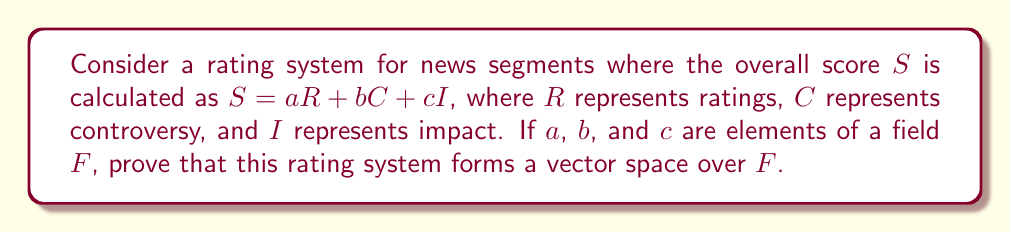Can you solve this math problem? To prove that the rating system forms a vector space over field $F$, we need to show that it satisfies the eight vector space axioms:

1. Closure under addition:
Let $S_1 = a_1R + b_1C + c_1I$ and $S_2 = a_2R + b_2C + c_2I$
$S_1 + S_2 = (a_1 + a_2)R + (b_1 + b_2)C + (c_1 + c_2)I$
Since $a_1 + a_2$, $b_1 + b_2$, and $c_1 + c_2$ are in $F$, $S_1 + S_2$ is in the vector space.

2. Commutativity of addition:
$S_1 + S_2 = (a_1 + a_2)R + (b_1 + b_2)C + (c_1 + c_2)I$
$= (a_2 + a_1)R + (b_2 + b_1)C + (c_2 + c_1)I = S_2 + S_1$

3. Associativity of addition:
$(S_1 + S_2) + S_3 = ((a_1 + a_2) + a_3)R + ((b_1 + b_2) + b_3)C + ((c_1 + c_2) + c_3)I$
$= (a_1 + (a_2 + a_3))R + (b_1 + (b_2 + b_3))C + (c_1 + (c_2 + c_3))I = S_1 + (S_2 + S_3)$

4. Additive identity:
The zero vector is $0 = 0R + 0C + 0I$, where $0 \in F$
$S + 0 = (a + 0)R + (b + 0)C + (c + 0)I = S$

5. Additive inverse:
For any $S = aR + bC + cI$, its additive inverse is $-S = (-a)R + (-b)C + (-c)I$
$S + (-S) = (a + (-a))R + (b + (-b))C + (c + (-c))I = 0R + 0C + 0I = 0$

6. Closure under scalar multiplication:
For any scalar $k \in F$ and $S = aR + bC + cI$
$kS = (ka)R + (kb)C + (kc)I$
Since $ka$, $kb$, and $kc$ are in $F$, $kS$ is in the vector space.

7. Distributivity of scalar multiplication with respect to vector addition:
$k(S_1 + S_2) = k((a_1 + a_2)R + (b_1 + b_2)C + (c_1 + c_2)I)$
$= (k(a_1 + a_2))R + (k(b_1 + b_2))C + (k(c_1 + c_2))I$
$= (ka_1 + ka_2)R + (kb_1 + kb_2)C + (kc_1 + kc_2)I$
$= (ka_1R + kb_1C + kc_1I) + (ka_2R + kb_2C + kc_2I) = kS_1 + kS_2$

8. Distributivity of scalar multiplication with respect to field addition:
$(k_1 + k_2)S = ((k_1 + k_2)a)R + ((k_1 + k_2)b)C + ((k_1 + k_2)c)I$
$= (k_1a + k_2a)R + (k_1b + k_2b)C + (k_1c + k_2c)I$
$= (k_1aR + k_1bC + k_1cI) + (k_2aR + k_2bC + k_2cI) = k_1S + k_2S$

Since all eight vector space axioms are satisfied, the rating system forms a vector space over field $F$.
Answer: The rating system forms a vector space over $F$. 